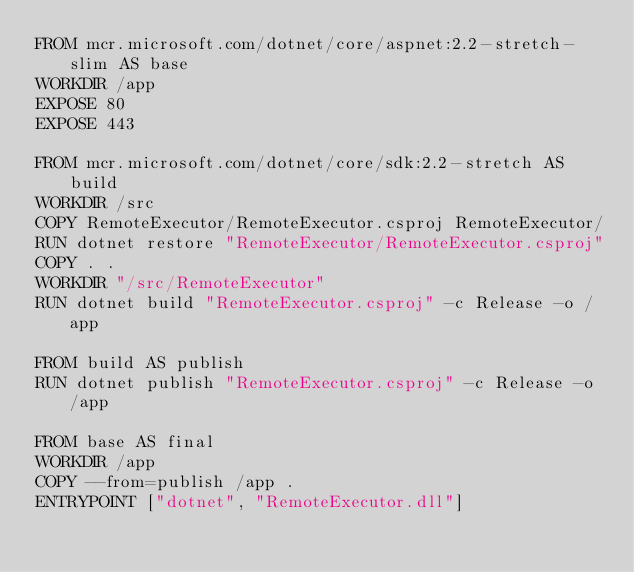<code> <loc_0><loc_0><loc_500><loc_500><_Dockerfile_>FROM mcr.microsoft.com/dotnet/core/aspnet:2.2-stretch-slim AS base
WORKDIR /app
EXPOSE 80
EXPOSE 443

FROM mcr.microsoft.com/dotnet/core/sdk:2.2-stretch AS build
WORKDIR /src
COPY RemoteExecutor/RemoteExecutor.csproj RemoteExecutor/
RUN dotnet restore "RemoteExecutor/RemoteExecutor.csproj"
COPY . .
WORKDIR "/src/RemoteExecutor"
RUN dotnet build "RemoteExecutor.csproj" -c Release -o /app

FROM build AS publish
RUN dotnet publish "RemoteExecutor.csproj" -c Release -o /app

FROM base AS final
WORKDIR /app
COPY --from=publish /app .
ENTRYPOINT ["dotnet", "RemoteExecutor.dll"]
</code> 